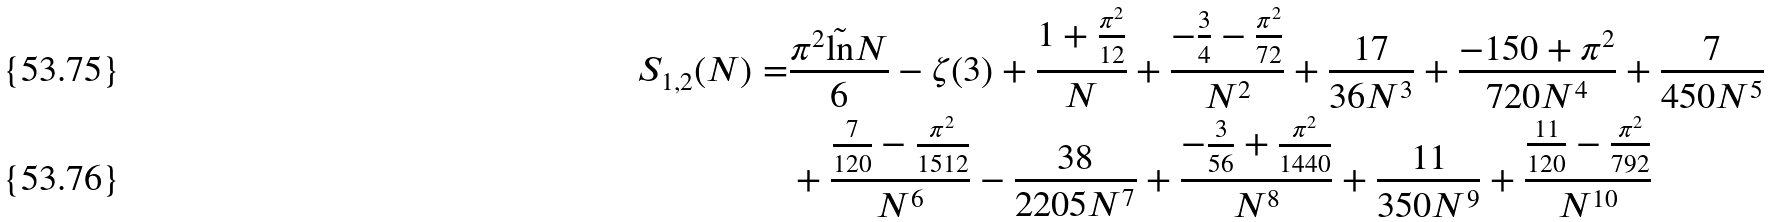<formula> <loc_0><loc_0><loc_500><loc_500>S _ { 1 , 2 } ( N ) = & \frac { \pi ^ { 2 } \tilde { \ln } N } { 6 } - \zeta ( 3 ) + \frac { 1 + \frac { \pi ^ { 2 } } { 1 2 } } { N } + \frac { - \frac { 3 } { 4 } - \frac { \pi ^ { 2 } } { 7 2 } } { N ^ { 2 } } + \frac { 1 7 } { 3 6 N ^ { 3 } } + \frac { - 1 5 0 + \pi ^ { 2 } } { 7 2 0 N ^ { 4 } } + \frac { 7 } { 4 5 0 N ^ { 5 } } \\ & + \frac { \frac { 7 } { 1 2 0 } - \frac { \pi ^ { 2 } } { 1 5 1 2 } } { N ^ { 6 } } - \frac { 3 8 } { 2 2 0 5 N ^ { 7 } } + \frac { - \frac { 3 } { 5 6 } + \frac { \pi ^ { 2 } } { 1 4 4 0 } } { N ^ { 8 } } + \frac { 1 1 } { 3 5 0 N ^ { 9 } } + \frac { \frac { 1 1 } { 1 2 0 } - \frac { \pi ^ { 2 } } { 7 9 2 } } { N ^ { 1 0 } }</formula> 